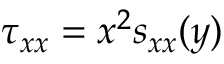Convert formula to latex. <formula><loc_0><loc_0><loc_500><loc_500>\tau _ { x x } = x ^ { 2 } s _ { x x } ( y )</formula> 